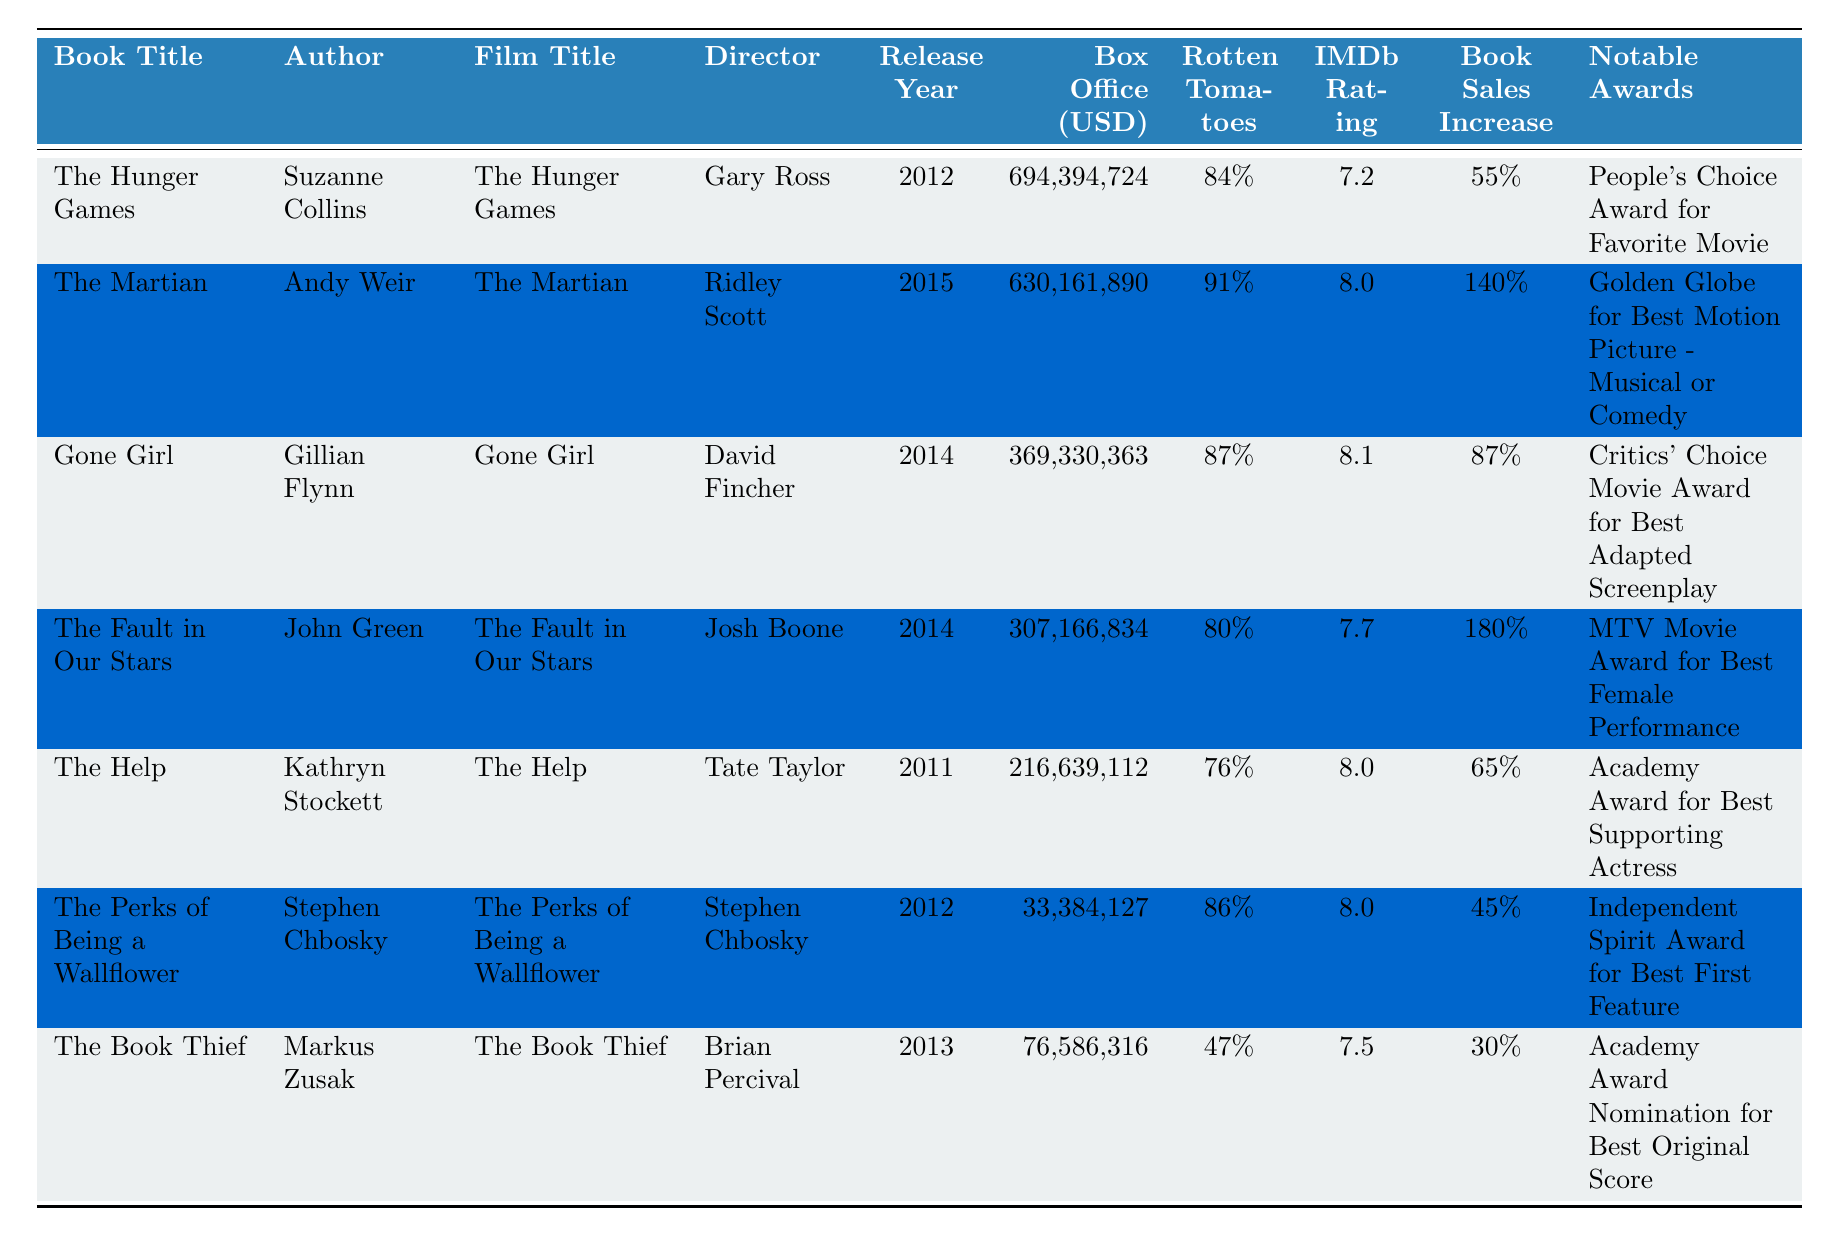What is the box office revenue for "Gone Girl"? The box office revenue for "Gone Girl" can be found in the "Box Office (USD)" column corresponding to its row. It is listed as "369,330,363".
Answer: 369,330,363 Which film had the highest Rotten Tomatoes score? To find which film had the highest Rotten Tomatoes score, we can compare the scores listed in the "Rotten Tomatoes Score" column. The highest score is "91%", which belongs to "The Martian".
Answer: The Martian What is the total increase in book sales for "The Fault in Our Stars" and "Gone Girl"? For "The Fault in Our Stars," the book sales increase is listed as "180%", and for "Gone Girl," it's "87%". Adding these two percentages gives us 180 + 87 = 267%.
Answer: 267% Did "The Help" win an Academy Award? In the "Notable Awards" column for "The Help," it states "Academy Award for Best Supporting Actress," confirming that it did indeed win an Academy Award.
Answer: Yes Which book had the lowest box office revenue? By looking at the "Box Office (USD)" column, we can see the values for all films. The lowest value is "33,384,127," which corresponds to "The Perks of Being a Wallflower."
Answer: The Perks of Being a Wallflower What is the average IMDb rating of the films listed? The IMDb ratings are 7.2, 8.0, 8.1, 7.7, 8.0, 8.0, and 7.5. To find the average, we sum these values (7.2 + 8.0 + 8.1 + 7.7 + 8.0 + 8.0 + 7.5 = 56.5) and divide by the number of films (7). Thus, the average is 56.5/7 ≈ 8.07.
Answer: 8.07 Which book saw a higher sales increase, "The Hunger Games" or "The Book Thief"? "The Hunger Games" has a book sales increase of "55%", while "The Book Thief" has an increase of "30%." Comparing these, "The Hunger Games" saw a higher increase.
Answer: The Hunger Games How many films had an IMDb rating above 8? Looking at the "IMDb Rating" column, the films with ratings above 8 are "The Martian" (8.0), "Gone Girl" (8.1), "The Help" (8.0), and "The Perks of Being a Wallflower" (8.0). That's a total of 4 films.
Answer: 4 